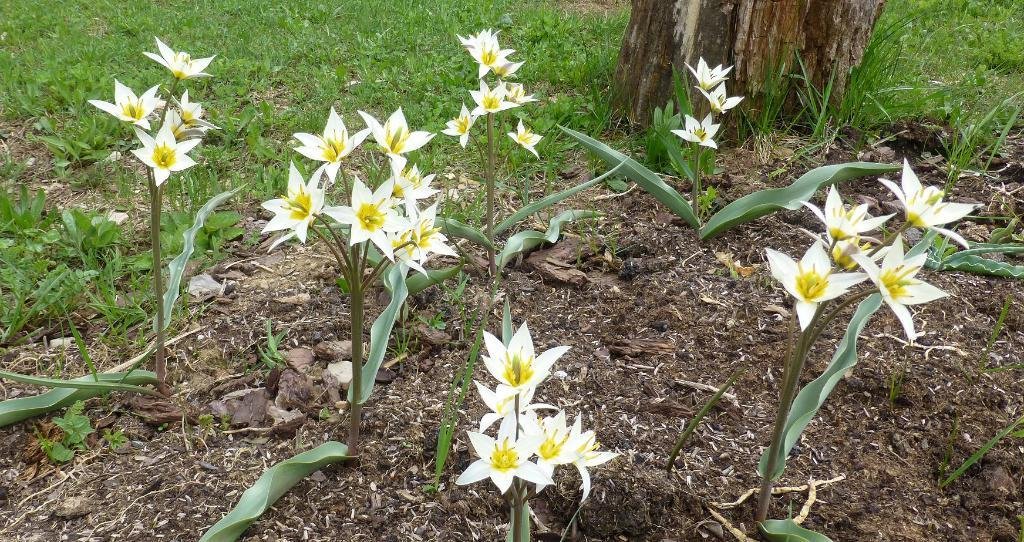What type of plants are present in the image? There are plants with white flowers in the image. What material is visible in the image? There is glass visible in the image. What type of structure can be seen in the image? There is a wooden pole in the image. How does the gate open in the image? There is no gate present in the image. What type of view can be seen through the glass in the image? The image does not show a view through the glass, as it only shows the glass itself. 